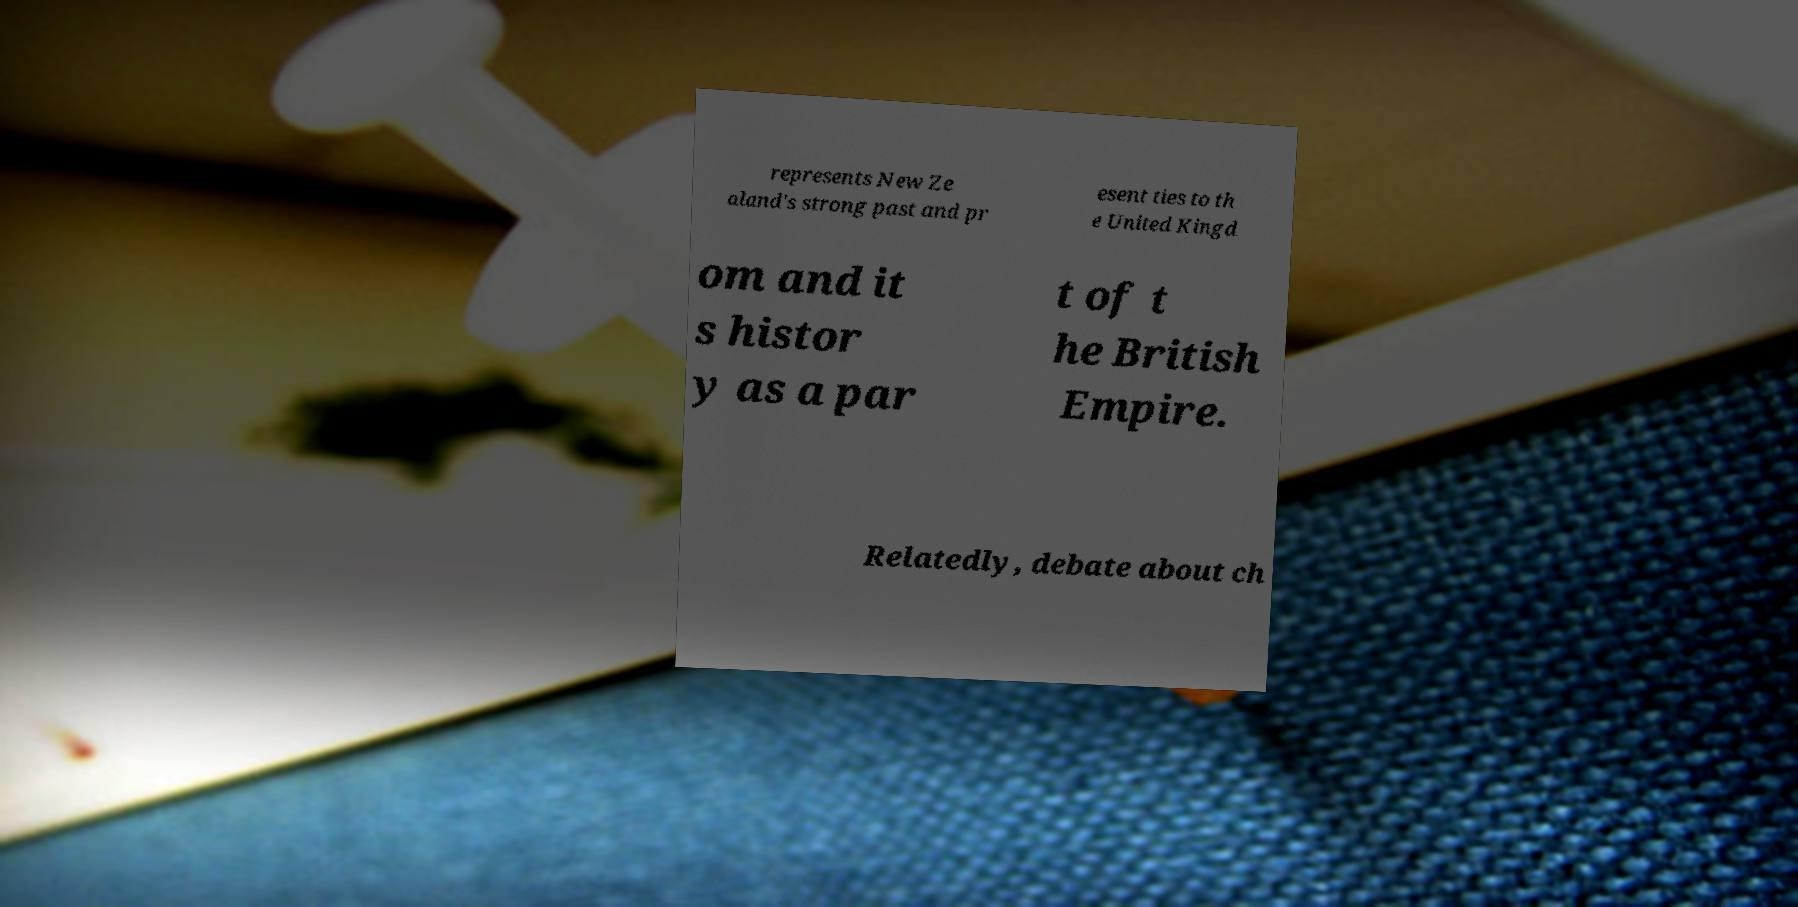What messages or text are displayed in this image? I need them in a readable, typed format. represents New Ze aland's strong past and pr esent ties to th e United Kingd om and it s histor y as a par t of t he British Empire. Relatedly, debate about ch 